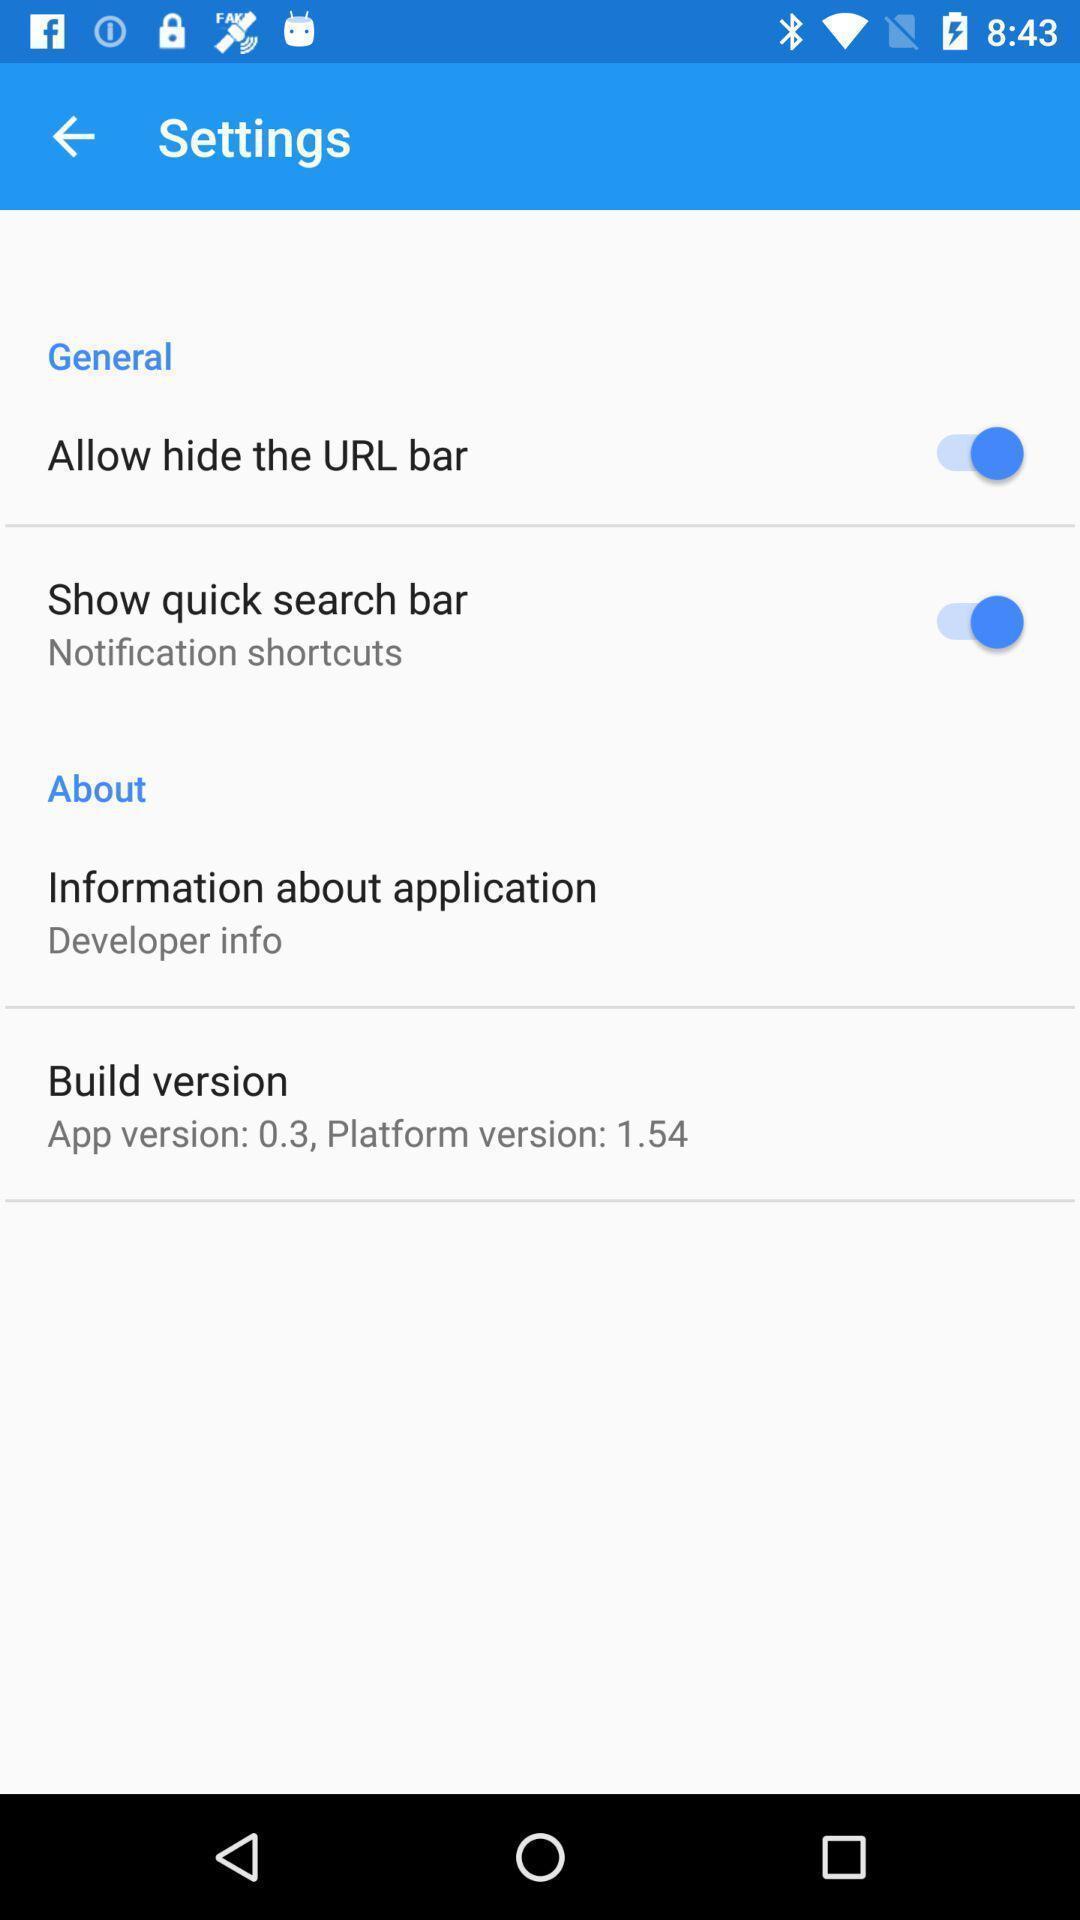Describe this image in words. Screen displaying multiple setting options. 